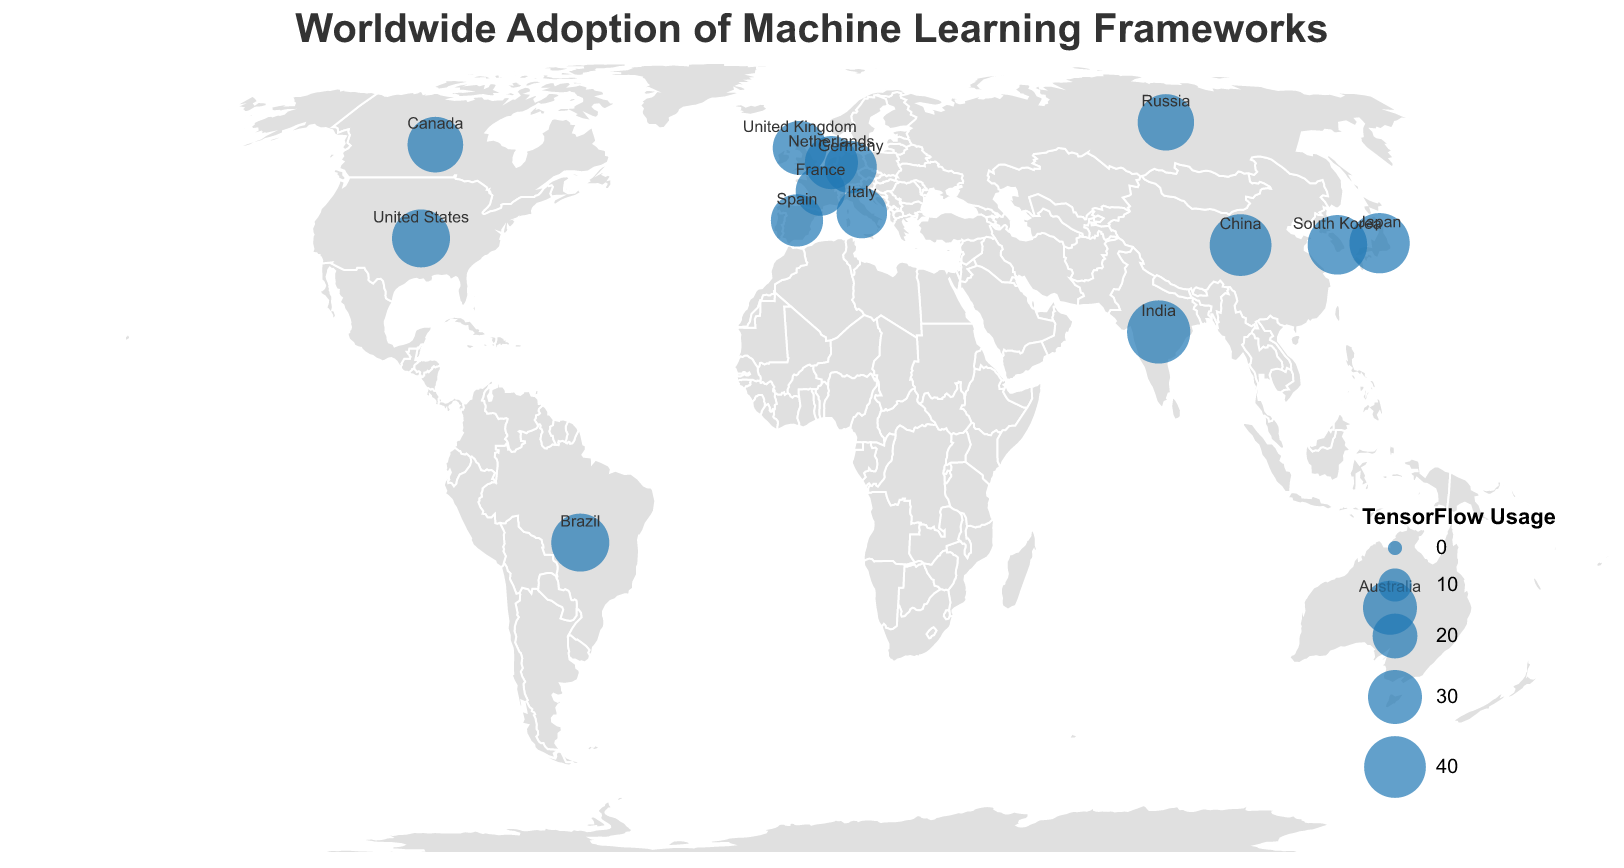Which country has the highest adoption rate of TensorFlow? China has the highest adoption rate of TensorFlow. From the plot, the size of the circles represents the adoption rate, and the tooltip indicates China has 40% for TensorFlow usage.
Answer: China Which two countries have equal adoption rates for XGBoost? The plot's tooltip shows that both the United States and Germany have a 5% adoption rate for XGBoost.
Answer: United States and Germany What is the total adoption rate of Scikit-learn across France and Australia? The tooltip indicates France has a 24% adoption rate for Scikit-learn, and Australia has 23%. Summing these gives 24 + 23 = 47%.
Answer: 47% Among Canada, Spain, and Italy, which country has the highest adoption rate for Keras? The tooltip shows that Canada, Spain, and Italy have Keras adoption rates of 14%, 15%, and 14%, respectively. Spain has the highest adoption rate among these three countries, with 15%.
Answer: Spain What is the adoption rate difference between TensorFlow and PyTorch in the United Kingdom? The tooltip shows that the United Kingdom has a 30% adoption rate for TensorFlow and a 35% adoption rate for PyTorch. The difference is 35 - 30 = 5%.
Answer: 5% What is the average adoption rate of PyTorch across all listed countries? To find the average of PyTorch adoption rates across all countries, first sum all PyTorch percentages: 30 + 25 + 35 + 32 + 28 + 22 + 28 + 30 + 27 + 25 + 29 + 26 + 31 + 29 + 33 = 430. Divide by the number of countries, which is 15. The average is 430 / 15 = 28.67%.
Answer: 28.67% Which country has the lowest adoption rate for TensorFlow? The tooltip indicates that France has the lowest adoption rate for TensorFlow at 25%.
Answer: France How many countries have a TensorFlow adoption rate greater than 30%? From the plot, countries with TensorFlow adoption rates greater than 30% are the United States (35%), China (40%), Japan (38%), India (42%), South Korea (37%), and Brazil (35%). There are 6 such countries.
Answer: 6 Which country displays the highest variance in adoption rates across the frameworks listed? To determine the country with the highest variance in adoption rates: for each country, compute the variance of its adoption rates. Without performing the precise calculations, it can be visually assessed from tooltip values that India shows considerable differences among adoption rates (42, 22, 18, 13, 5), suggesting it might have the highest variance.
Answer: India 